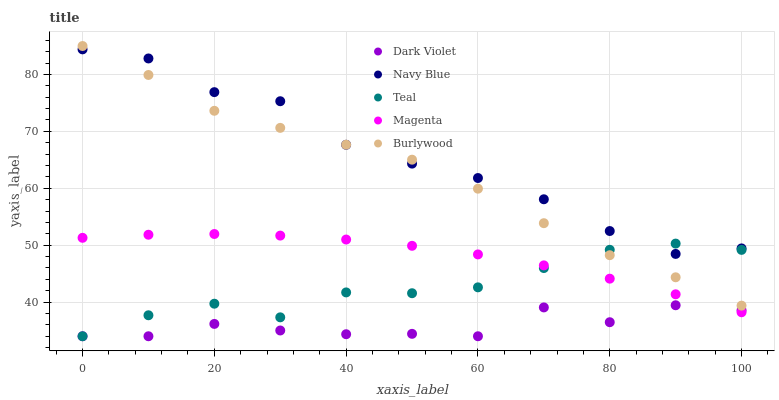Does Dark Violet have the minimum area under the curve?
Answer yes or no. Yes. Does Navy Blue have the maximum area under the curve?
Answer yes or no. Yes. Does Magenta have the minimum area under the curve?
Answer yes or no. No. Does Magenta have the maximum area under the curve?
Answer yes or no. No. Is Magenta the smoothest?
Answer yes or no. Yes. Is Dark Violet the roughest?
Answer yes or no. Yes. Is Navy Blue the smoothest?
Answer yes or no. No. Is Navy Blue the roughest?
Answer yes or no. No. Does Teal have the lowest value?
Answer yes or no. Yes. Does Magenta have the lowest value?
Answer yes or no. No. Does Burlywood have the highest value?
Answer yes or no. Yes. Does Navy Blue have the highest value?
Answer yes or no. No. Is Magenta less than Navy Blue?
Answer yes or no. Yes. Is Burlywood greater than Magenta?
Answer yes or no. Yes. Does Teal intersect Dark Violet?
Answer yes or no. Yes. Is Teal less than Dark Violet?
Answer yes or no. No. Is Teal greater than Dark Violet?
Answer yes or no. No. Does Magenta intersect Navy Blue?
Answer yes or no. No. 